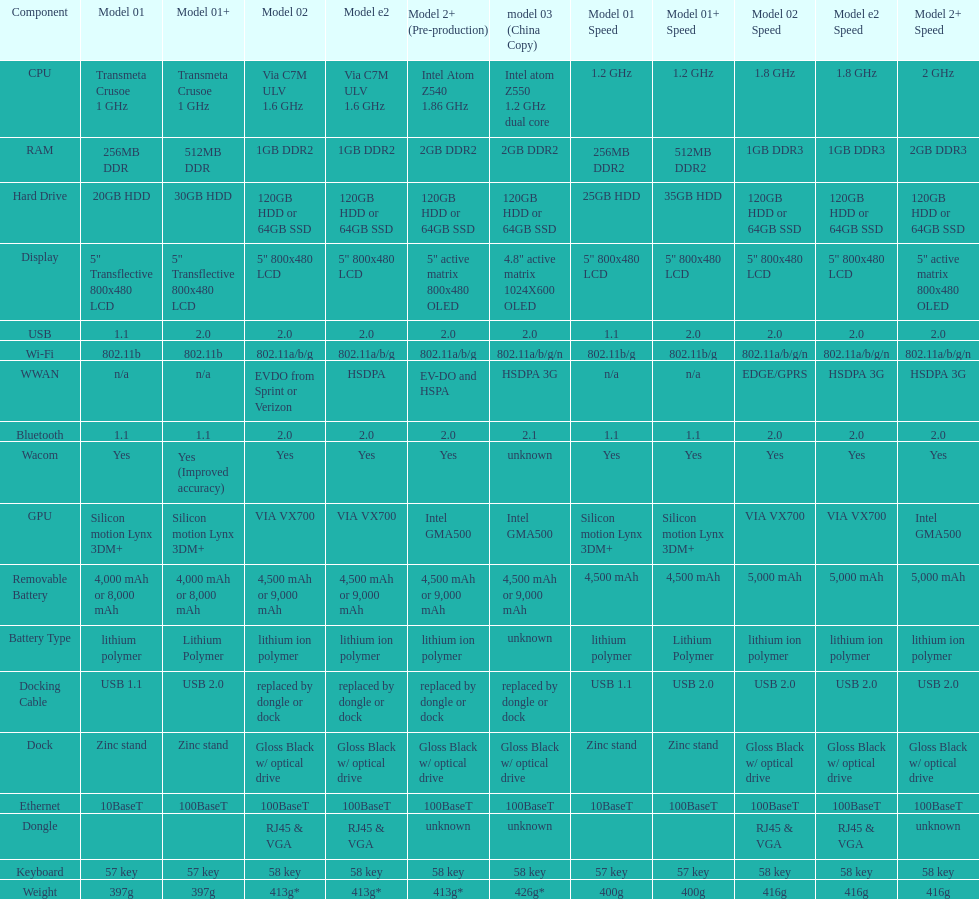What is the part prior to usb? Display. 